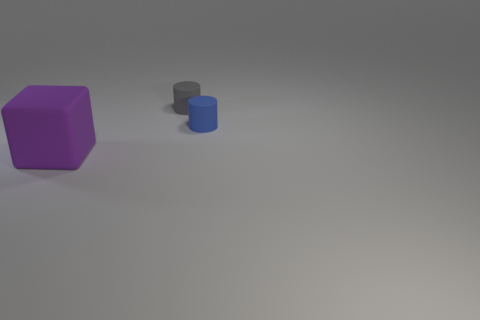There is a thing that is both behind the purple matte object and on the left side of the tiny blue rubber cylinder; what is its color?
Keep it short and to the point. Gray. What number of tiny cylinders are on the left side of the object behind the tiny blue rubber cylinder?
Offer a terse response. 0. Is there a blue thing of the same shape as the tiny gray matte object?
Give a very brief answer. Yes. Do the tiny matte thing that is left of the blue thing and the object that is in front of the blue matte thing have the same shape?
Ensure brevity in your answer.  No. How many objects are blue cylinders or tiny purple objects?
Ensure brevity in your answer.  1. The other rubber object that is the same shape as the gray rubber object is what size?
Give a very brief answer. Small. Is the number of blue things that are right of the big rubber cube greater than the number of big green rubber objects?
Give a very brief answer. Yes. Are the cube and the tiny gray cylinder made of the same material?
Your answer should be compact. Yes. What number of objects are either things right of the purple matte thing or objects that are behind the big rubber cube?
Your response must be concise. 2. There is another tiny matte object that is the same shape as the small blue matte object; what color is it?
Give a very brief answer. Gray. 